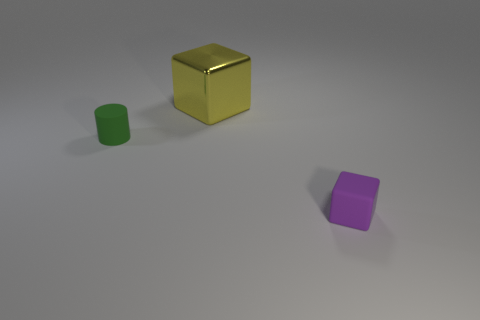What number of things are matte objects that are to the right of the green thing or small cubes that are in front of the large thing?
Give a very brief answer. 1. There is another big object that is the same shape as the purple thing; what material is it?
Your response must be concise. Metal. Is there a green matte cylinder of the same size as the purple cube?
Make the answer very short. Yes. There is a object that is right of the green cylinder and in front of the large yellow metal object; what is it made of?
Provide a succinct answer. Rubber. What number of matte objects are tiny brown cylinders or yellow objects?
Provide a succinct answer. 0. What is the shape of the tiny thing that is made of the same material as the purple block?
Offer a terse response. Cylinder. How many things are both behind the small matte cube and in front of the large object?
Ensure brevity in your answer.  1. Is there anything else that has the same shape as the small green matte object?
Ensure brevity in your answer.  No. What size is the thing behind the tiny rubber cylinder?
Ensure brevity in your answer.  Large. What number of other objects are there of the same color as the big metal cube?
Keep it short and to the point. 0. 